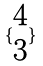<formula> <loc_0><loc_0><loc_500><loc_500>\{ \begin{matrix} 4 \\ 3 \end{matrix} \}</formula> 